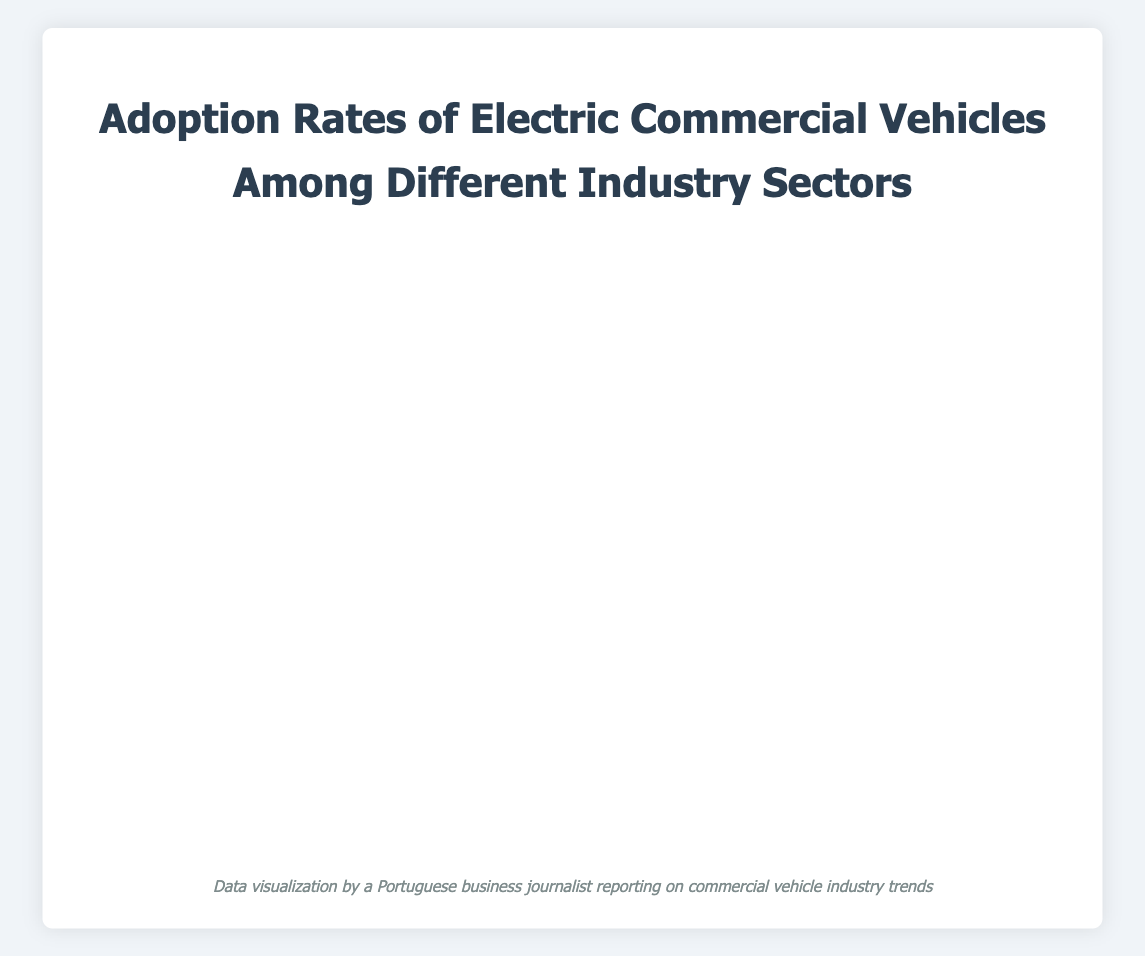what is the title of the chart? The title of the chart is displayed at the top of the figure in a large, bold font. It describes the general theme of the visualized data.
Answer: Adoption Rates of Electric Commercial Vehicles Among Different Industry Sectors How many companies are included in the chart? To determine the number of companies, count the number of distinct bubble points in the chart. Each bubble represents a different company.
Answer: 7 Which company has the highest adoption rate of electric commercial vehicles? Find the bubble with the highest x-coordinate value, as it represents the adoption rate percentage.
Answer: Amazon What is the average adoption rate across all industries shown? To calculate the average adoption rate, sum the adoption rates of all companies and divide by the number of companies. Calculation: (55 + 60 + 45 + 50 + 38 + 30 + 25) / 7 = 43.29
Answer: 43.29% Which industry has the largest fleet size, and what is the size? Identify the bubble with the largest radius since the radius represents the fleet size. The legend or tooltip should display the industry's name and fleet size.
Answer: E-Commerce (Amazon) with fleet size of 5000 Compare the adoption rates between the Courier Services and Public Transportation industries. Find the x-coordinates of the bubbles representing Courier Services and Public Transportation. Subtract the smaller value from the larger one to compare their adoption rates. Calculation: 50 (FedEx) - 38 (Transport for London) = 12%
Answer: Courier Services has a 12% higher adoption rate Which company has the longest average duration in years for using electric commercial vehicles? Find the bubble with the highest y-coordinate value, as it represents the average duration in years.
Answer: Waste Management Inc What is the median average duration of electric vehicles usage across all companies? List all y-coordinate values (2, 3, 3, 4, 5, 5, 6), find the middle value or average of the two middle values if the count is even. The median is the middle value in this sorted list.
Answer: 4 years Identify the industry with both a high fleet size and a high adoption rate. Look for bubbles with larger radii (fleet size) and high x-coordinate values (adoption rates).
Answer: E-Commerce (Amazon) Is there a notable trend between fleet size and average duration? Observe the relationship between bubble sizes and their y-coordinates. Larger bubbles representing larger fleets tend to have varied average durations; no direct positive or negative trend is stated.
Answer: No clear trend 